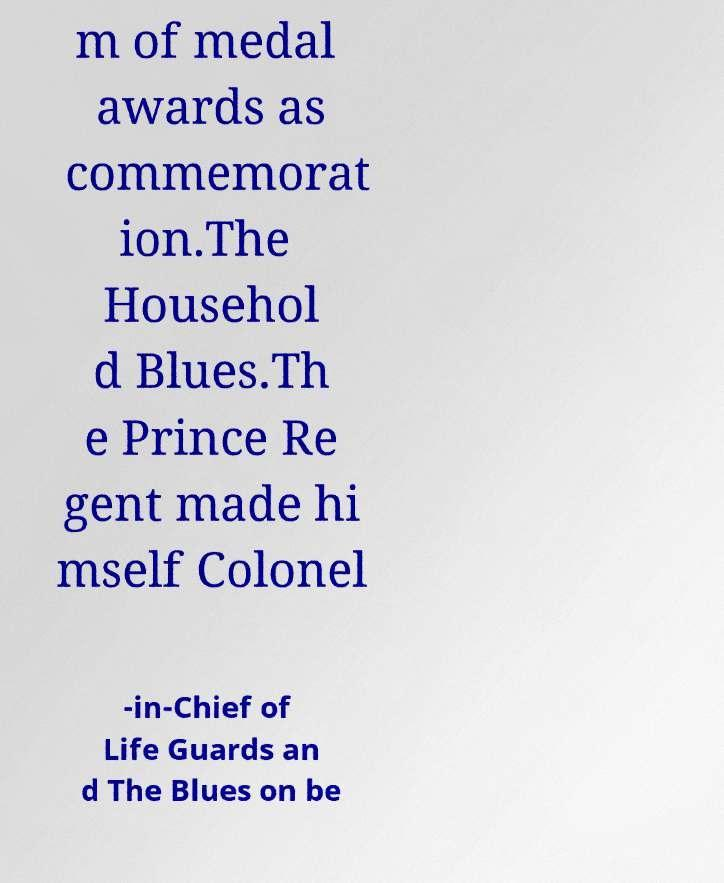I need the written content from this picture converted into text. Can you do that? m of medal awards as commemorat ion.The Househol d Blues.Th e Prince Re gent made hi mself Colonel -in-Chief of Life Guards an d The Blues on be 